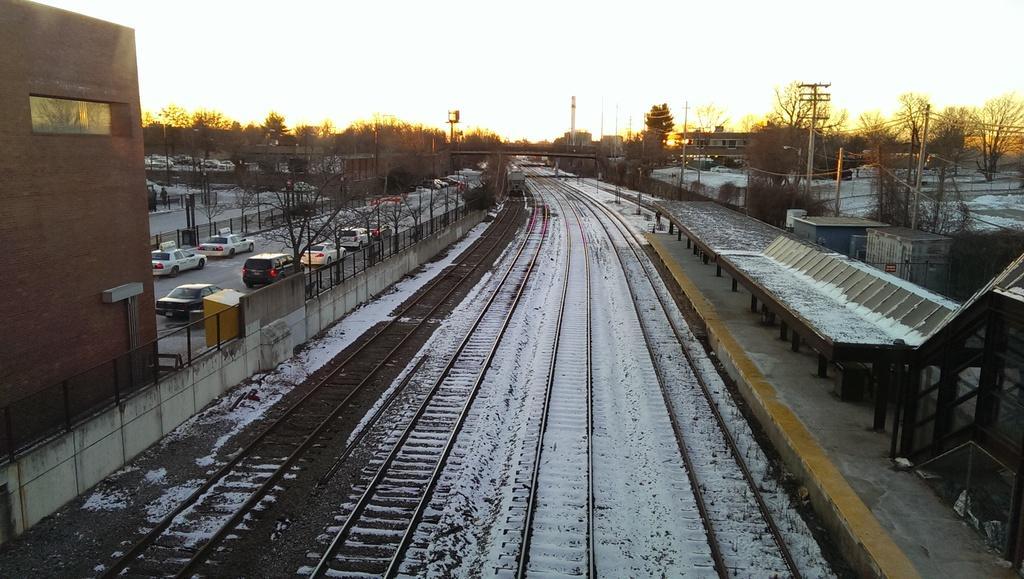How would you summarize this image in a sentence or two? In the Center of the image there is a railway track and it is covered with snow. On the left and on the right there are many trees and also buildings. Image also consists of vehicles present on the road. Sky is also visible. Poles with wires are also present in this image. 